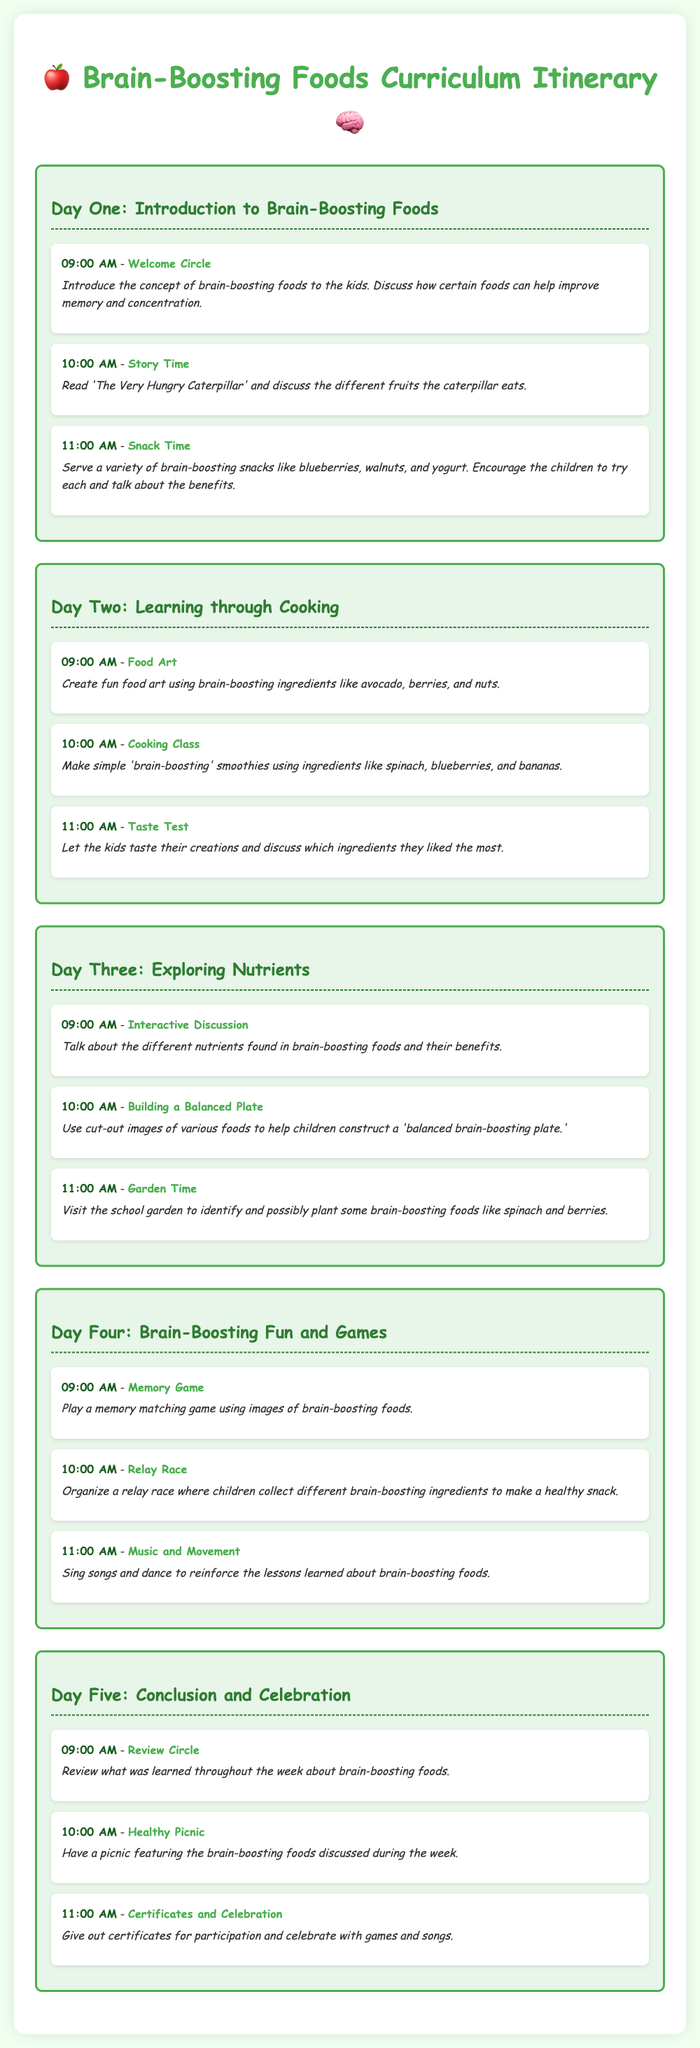What time does the Welcome Circle begin? The Welcome Circle starts at 09:00 AM on Day One.
Answer: 09:00 AM What activity involves creating food art? The Food Art activity takes place on Day Two at 09:00 AM.
Answer: Food Art How many days are included in the itinerary? The itinerary covers a total of five days of activities.
Answer: Five What brain-boosting ingredients are used in the smoothie? The smoothie is made with spinach, blueberries, and bananas during the Cooking Class on Day Two.
Answer: Spinach, blueberries, and bananas What is the theme for Day Four? Day Four focuses on fun and games related to brain-boosting foods.
Answer: Brain-Boosting Fun and Games Which activity concludes the week? The last activity is the Certificates and Celebration, which takes place on Day Five at 11:00 AM.
Answer: Certificates and Celebration What is served during the Healthy Picnic? The picnic features brain-boosting foods discussed throughout the week.
Answer: Brain-boosting foods Which nutrient-focused discussion takes place on Day Three? An interactive discussion about nutrients in brain-boosting foods occurs at 09:00 AM on Day Three.
Answer: Interactive Discussion 